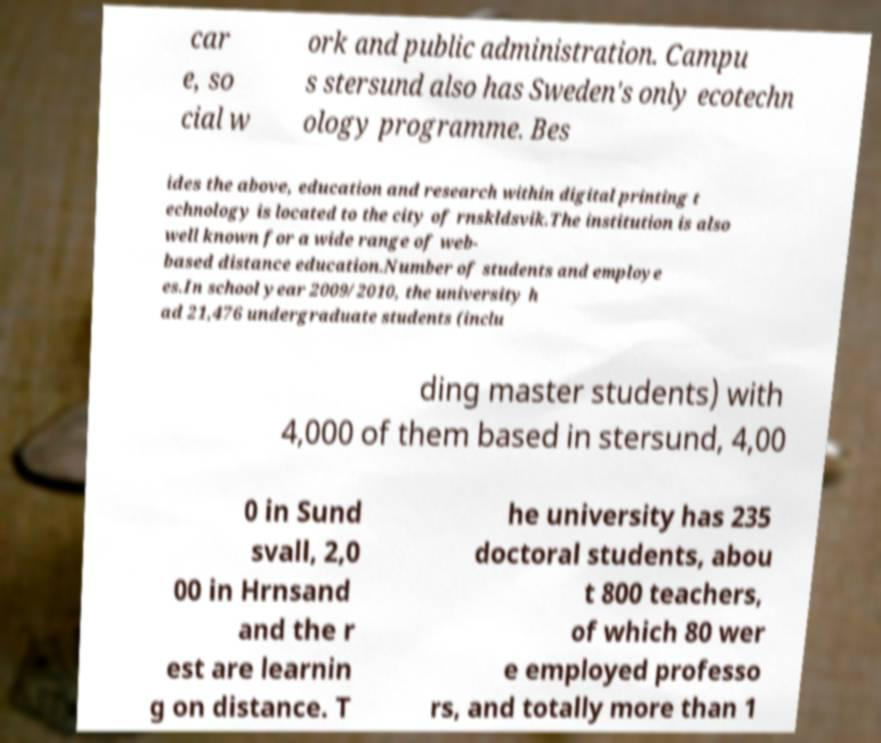Can you read and provide the text displayed in the image?This photo seems to have some interesting text. Can you extract and type it out for me? car e, so cial w ork and public administration. Campu s stersund also has Sweden's only ecotechn ology programme. Bes ides the above, education and research within digital printing t echnology is located to the city of rnskldsvik.The institution is also well known for a wide range of web- based distance education.Number of students and employe es.In school year 2009/2010, the university h ad 21,476 undergraduate students (inclu ding master students) with 4,000 of them based in stersund, 4,00 0 in Sund svall, 2,0 00 in Hrnsand and the r est are learnin g on distance. T he university has 235 doctoral students, abou t 800 teachers, of which 80 wer e employed professo rs, and totally more than 1 